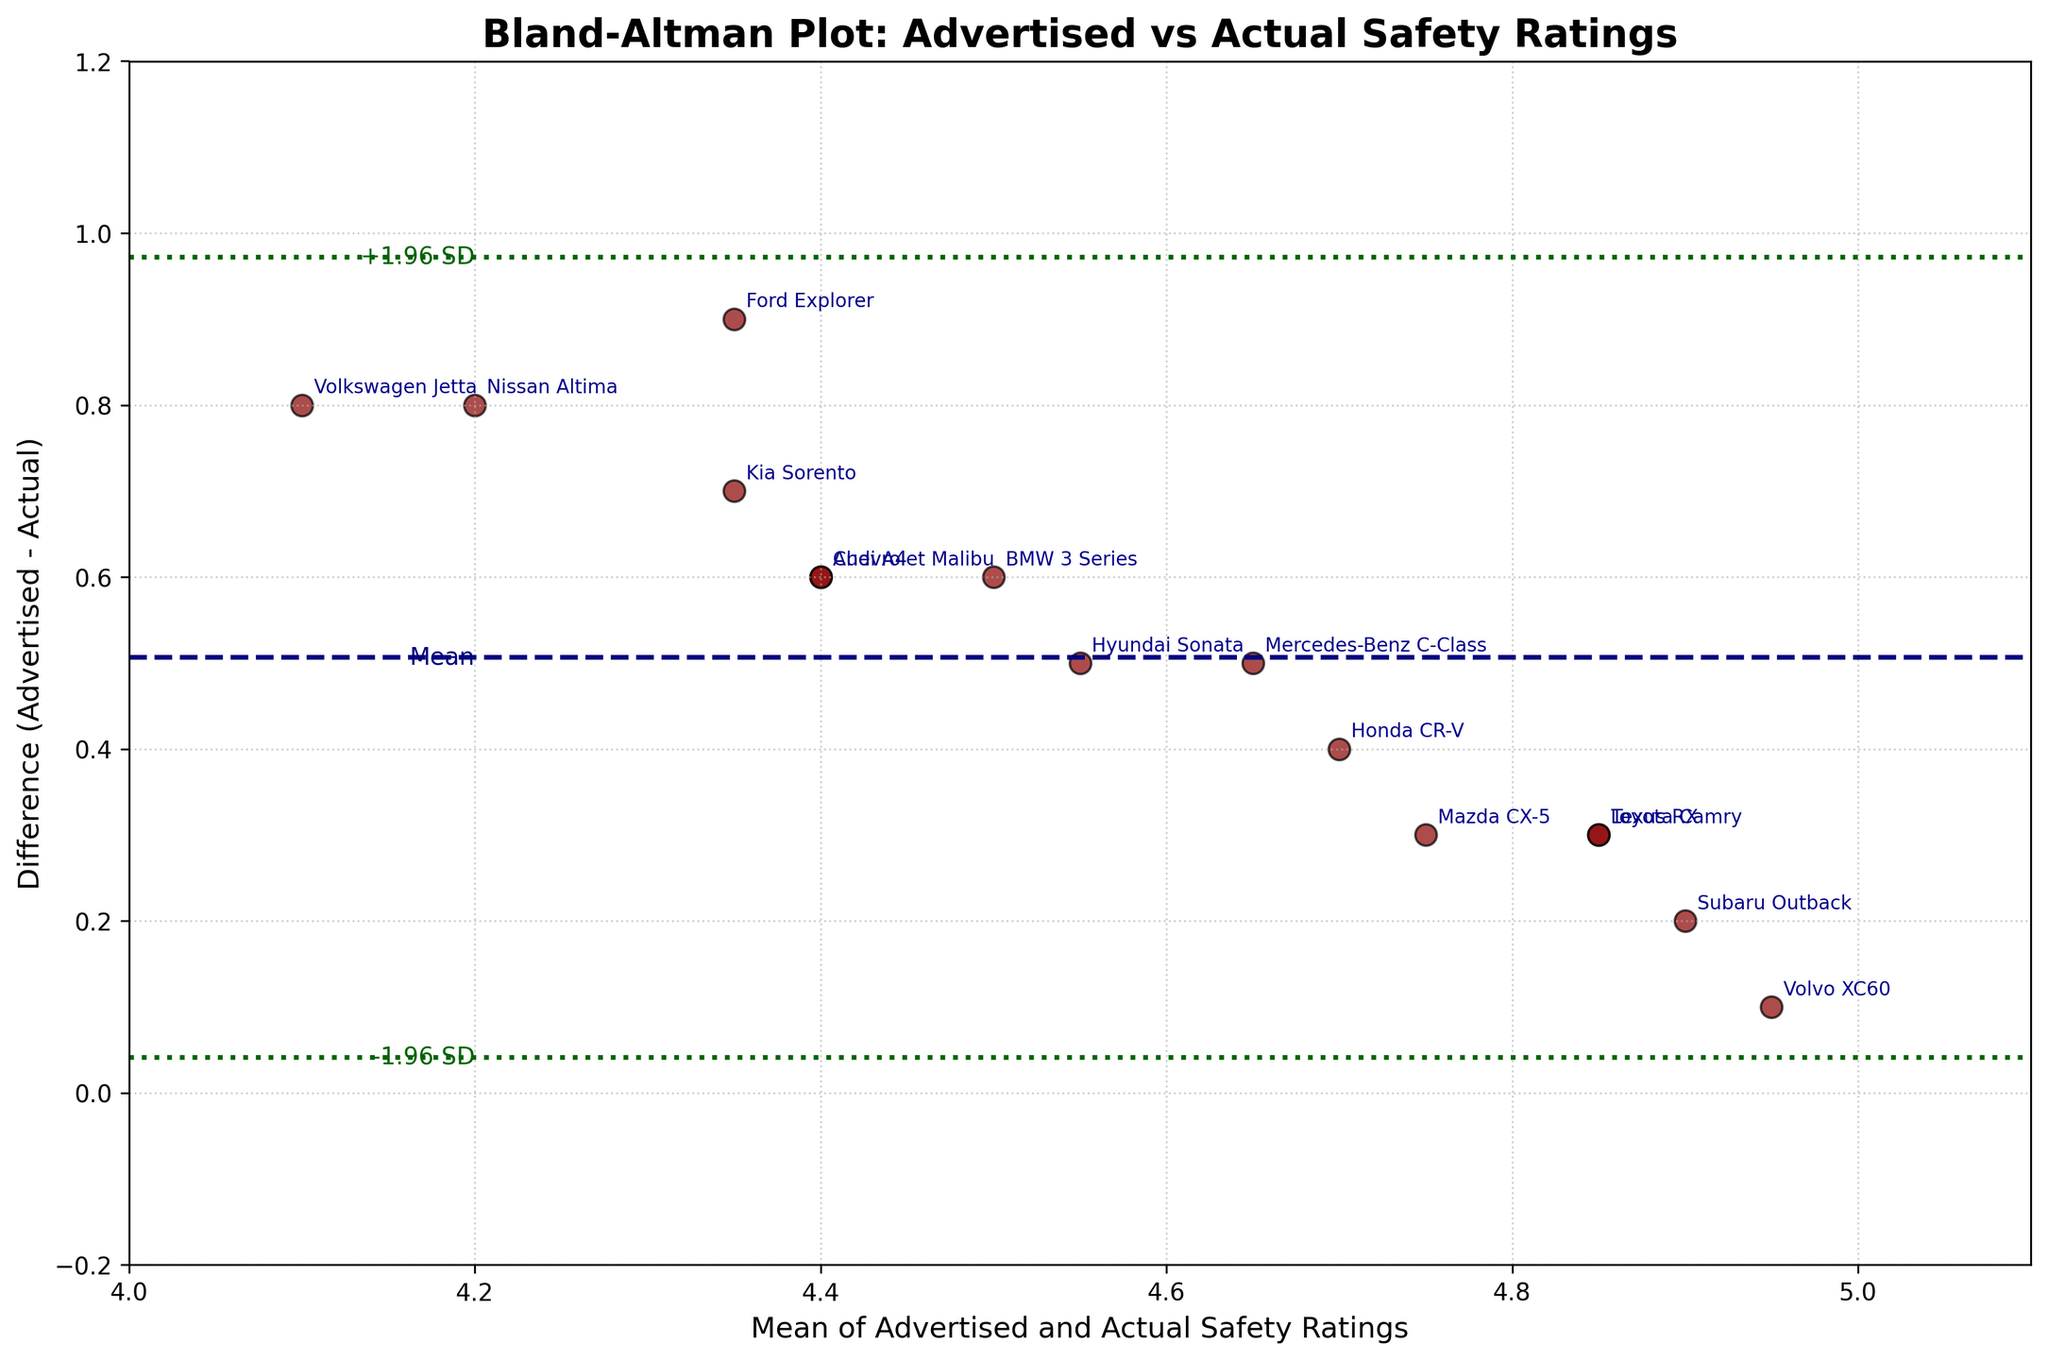what is the title of the plot? The title of the plot is displayed at the top in bold font. It reads "Bland-Altman Plot: Advertised vs Actual Safety Ratings".
Answer: Bland-Altman Plot: Advertised vs Actual Safety Ratings How many data points are plotted in the figure? Each scatter point represents a data point corresponding to a product from the provided data. By counting the points on the plot, it is observed that there are 15 data points.
Answer: 15 What does the horizontal navy dashed line represent? The navy dashed line represents the mean difference between the advertised and actual safety ratings, which is indicated by the label "Mean" next to the line.
Answer: Mean difference What are the green dotted lines on the plot representing? The green dotted lines represent the limits of agreement, which are the mean difference plus and minus 1.96 times the standard deviation of the differences. They are labeled as '+1.96 SD' and '-1.96 SD'.
Answer: Limits of agreement Which product shows the highest discrepancy between advertised and actual safety ratings? The highest discrepancy can be found by locating the point with the longest vertical distance from the mean difference line. This point belongs to the Nissan Altima, which shows the maximum positive discrepancy.
Answer: Nissan Altima What is the mean of advertised and actual safety ratings for the Toyota Camry? The mean of advertised and actual safety ratings is calculated as (advertised + actual) / 2. For the Toyota Camry, it is (5.0 + 4.7) / 2 = 4.85.
Answer: 4.85 Compare the discrepancies of the Hyundai Sonata and the Audi A4: Which one is higher? Both discrepancies can be compared by evaluating their vertical distances from the mean line. The Hyundai Sonata (difference of 0.5) has a higher discrepancy compared to the Audi A4 (difference of 0.6).
Answer: Hyundai Sonata Is there any product that has an actual safety rating close to the advertised rating, based on this plot? To find a product with minimal discrepancy, look for points close to the mean difference line. The Volvo XC60 shows an actual safety rating very close to the advertised rating (difference of 0.1).
Answer: Volvo XC60 What can be inferred from the spread of data points relative to the mean difference line? The spread of points around the mean difference line shows the variation in discrepancies. Points close to the mean difference line suggest minor discrepancies, whereas points further away indicate larger discrepancies. Most points lie within the limits of agreement, suggesting consistency in the discrepancies.
Answer: Consistency in discrepancies 